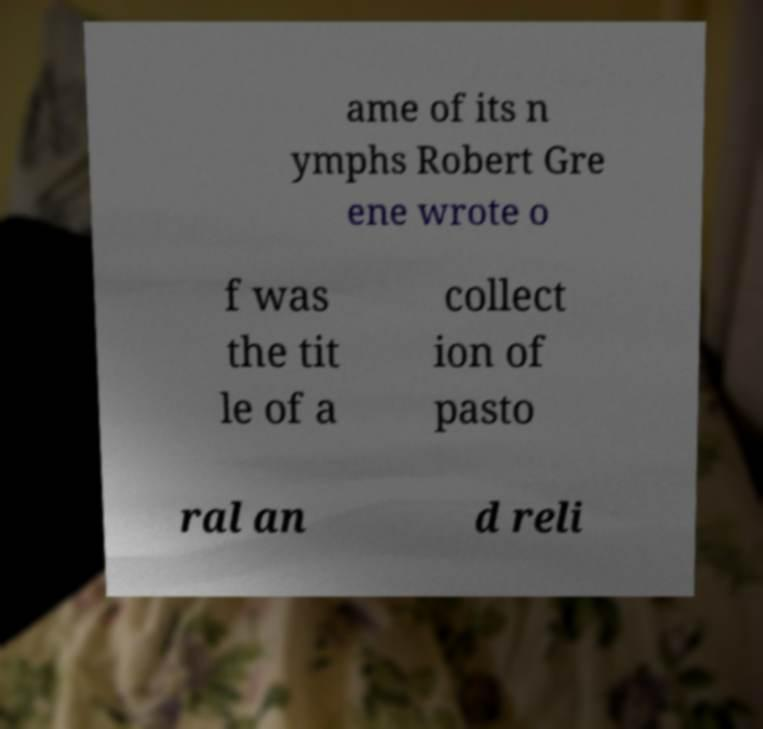Can you read and provide the text displayed in the image?This photo seems to have some interesting text. Can you extract and type it out for me? ame of its n ymphs Robert Gre ene wrote o f was the tit le of a collect ion of pasto ral an d reli 